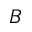Convert formula to latex. <formula><loc_0><loc_0><loc_500><loc_500>B</formula> 